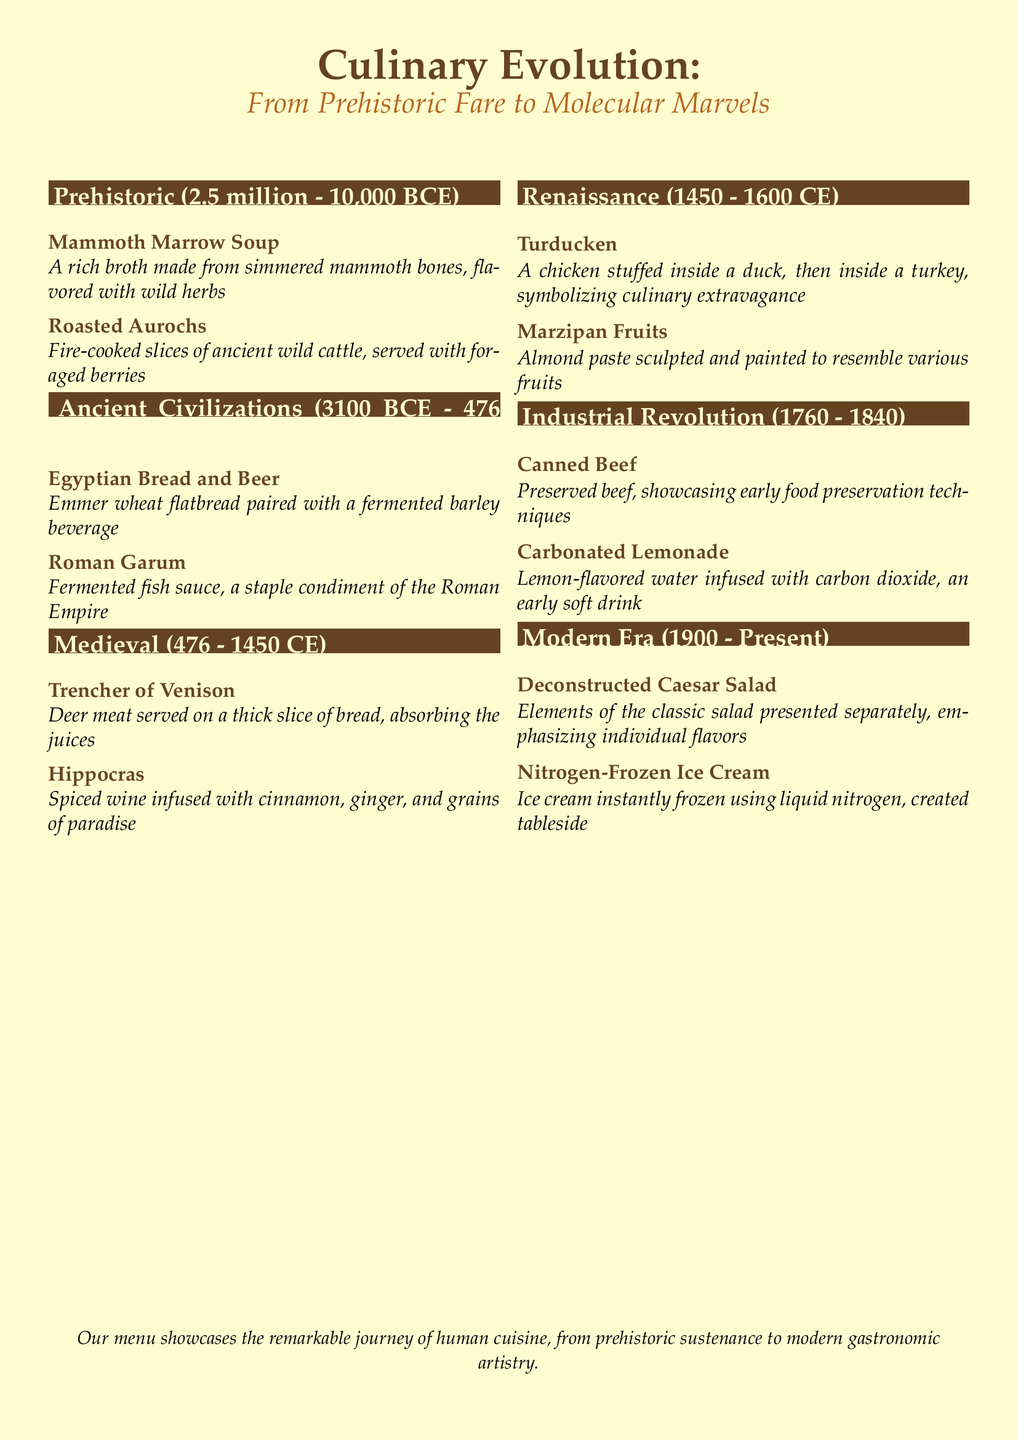What dish features mammoth bones? The dish featuring mammoth bones is described under the Prehistoric era, which is Mammoth Marrow Soup.
Answer: Mammoth Marrow Soup When was the Industrial Revolution period? The Industrial Revolution period is specified in the document as being from 1760 to 1840.
Answer: 1760 - 1840 What beverage is paired with Egyptian Bread? The document states that Egyptian Bread is paired with a fermented barley beverage, which is beer.
Answer: Beer Which dish symbolizes culinary extravagance during the Renaissance? Turducken is the dish that symbolizes culinary extravagance during the Renaissance period.
Answer: Turducken What modern dessert is created tableside? The modern dessert that is created tableside using liquid nitrogen is Nitrogen-Frozen Ice Cream.
Answer: Nitrogen-Frozen Ice Cream What era does the Trencher of Venison belong to? The Trencher of Venison belongs to the Medieval era, as indicated in the document.
Answer: Medieval Name one ingredient in Hippocras. The Hippocras includes spices such as cinnamon, ginger, or grains of paradise, as mentioned in the document.
Answer: Cinnamon How many dishes are presented in the Modern Era section? The Modern Era section comprises two dishes, as detailed in the menu.
Answer: Two 